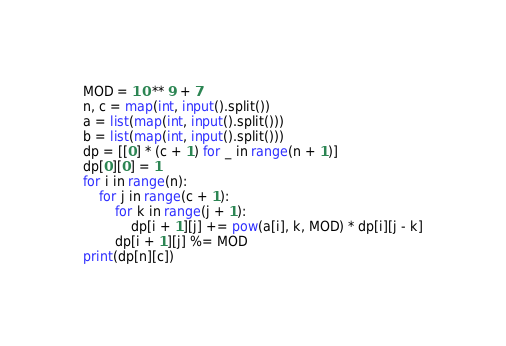<code> <loc_0><loc_0><loc_500><loc_500><_Python_>MOD = 10 ** 9 + 7
n, c = map(int, input().split())
a = list(map(int, input().split()))
b = list(map(int, input().split()))
dp = [[0] * (c + 1) for _ in range(n + 1)]
dp[0][0] = 1
for i in range(n):
    for j in range(c + 1):
        for k in range(j + 1):
            dp[i + 1][j] += pow(a[i], k, MOD) * dp[i][j - k]
        dp[i + 1][j] %= MOD
print(dp[n][c])
</code> 